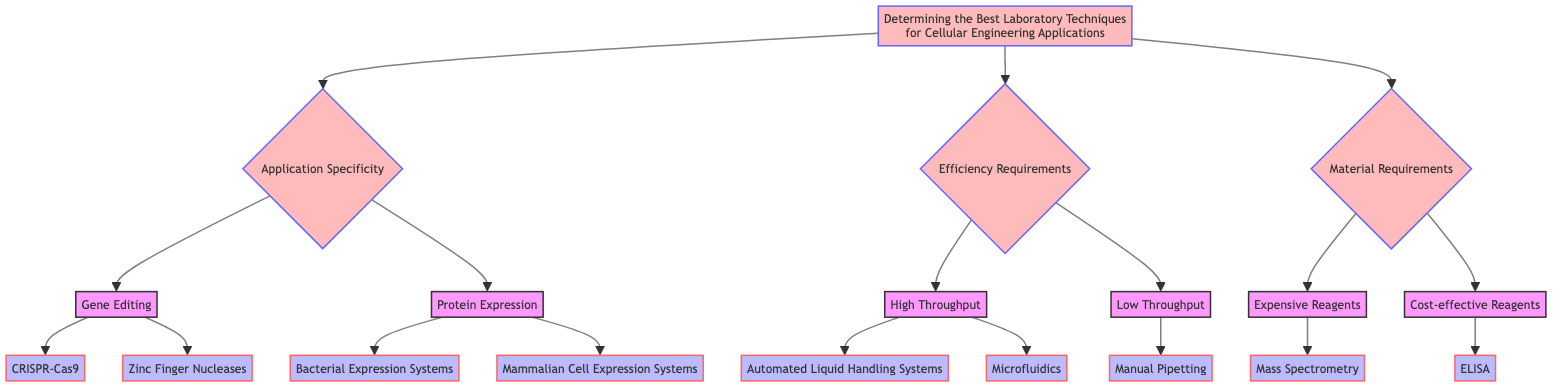What are the three main categories for selecting laboratory techniques in this diagram? The diagram shows three main categories for selecting laboratory techniques: Application Specificity, Efficiency Requirements, and Material Requirements. These categories are presented as the first level of nodes branching out from the main title.
Answer: Application Specificity, Efficiency Requirements, Material Requirements How many techniques are available under the "Gene Editing" option? In the diagram, the "Gene Editing" option has two techniques listed: CRISPR-Cas9 and Zinc Finger Nucleases. These techniques are represented as nodes connected to the "Gene Editing" parent node.
Answer: 2 Which technique is associated with the efficiency requirement of "Low Throughput"? The "Low Throughput" category contains one technique: Manual Pipetting. This can be seen directly connected to the "Low Throughput" node in the diagram.
Answer: Manual Pipetting What are the cons of using CRISPR-Cas9? The diagram lists two cons for CRISPR-Cas9: Potential off-target effects and Ethical concerns. These are provided as characteristics of this specific technique.
Answer: Potential off-target effects, Ethical concerns Which technique is noted for having high sensitivity and requires experienced personnel? The technique noted for high sensitivity and the requirement for experienced personnel is Mass Spectrometry. This is clearly indicated under the "Expensive Reagents" category in the diagram.
Answer: Mass Spectrometry If one prioritizes budget constraints, which technique would be advised under "Protein Expression"? Bacterial Expression Systems would be advised under "Protein Expression" if the priority is budget constraints since it is labeled as cost-effective, as indicated in the diagram.
Answer: Bacterial Expression Systems How many selection criteria are associated with Mammalian Cell Expression Systems? The diagram shows two selection criteria associated with Mammalian Cell Expression Systems: Requirement for eukaryotic-specific modifications and Budget available. This count can be determined by reviewing the corresponding section for this technique in the diagram.
Answer: 2 What is the main advantage of using Automated Liquid Handling Systems? The main advantage of using Automated Liquid Handling Systems is high precision. This is specifically stated in the diagram's pros section for this technique.
Answer: High precision Under which condition would one consider using Microfluidics? One would consider using Microfluidics under the condition of suitability for specific applications and expertise in microfluidics, as these are specified selection criteria related to this technique.
Answer: Suitable for specific application, Expertise in microfluidics 